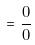Convert formula to latex. <formula><loc_0><loc_0><loc_500><loc_500>= \frac { 0 } { 0 }</formula> 